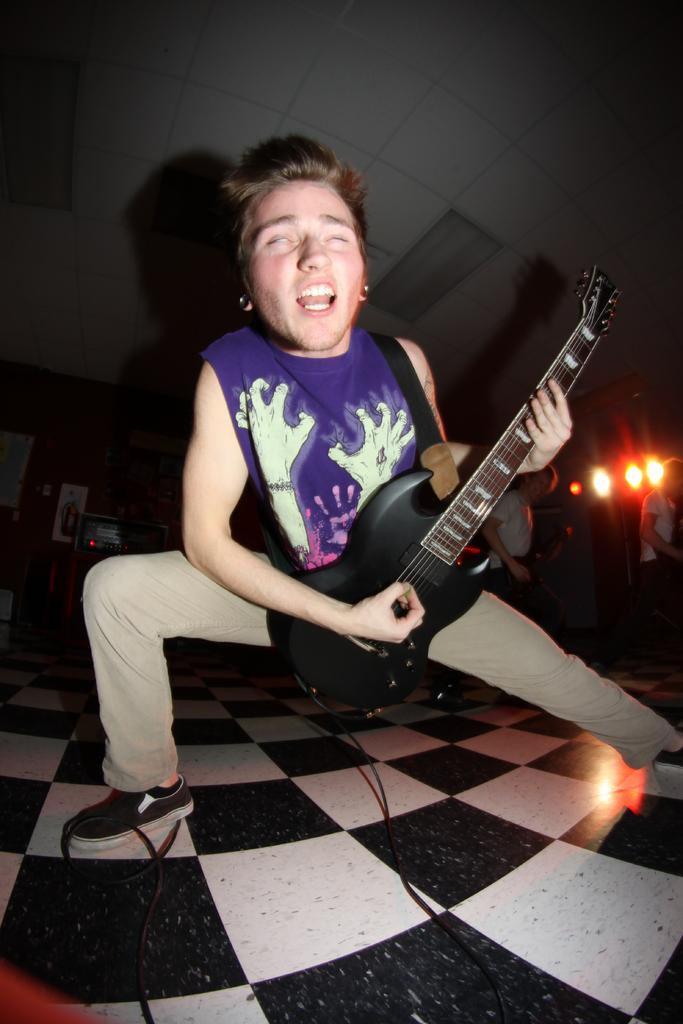What is the person in the image holding? The person is holding a guitar. Can you describe the other people visible in the image? There are other persons visible in the image, but their specific actions or features are not mentioned in the facts. What can be seen in the background of the image? There are lightings in the background. What type of shoe is the person wearing in the image? The facts provided do not mention any shoes or footwear, so we cannot determine the type of shoe the person is wearing. 